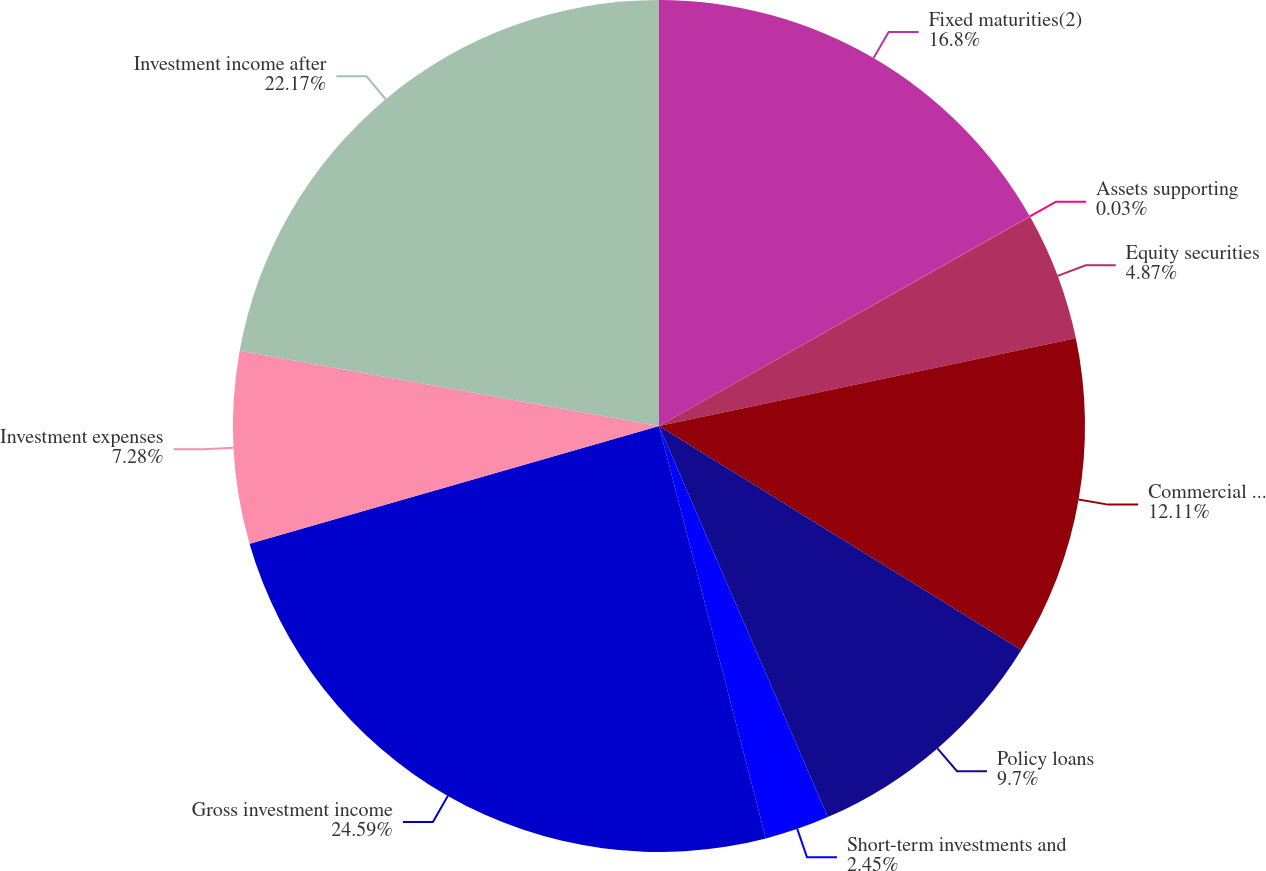<chart> <loc_0><loc_0><loc_500><loc_500><pie_chart><fcel>Fixed maturities(2)<fcel>Assets supporting<fcel>Equity securities<fcel>Commercial mortgage and other<fcel>Policy loans<fcel>Short-term investments and<fcel>Gross investment income<fcel>Investment expenses<fcel>Investment income after<nl><fcel>16.8%<fcel>0.03%<fcel>4.87%<fcel>12.11%<fcel>9.7%<fcel>2.45%<fcel>24.58%<fcel>7.28%<fcel>22.17%<nl></chart> 